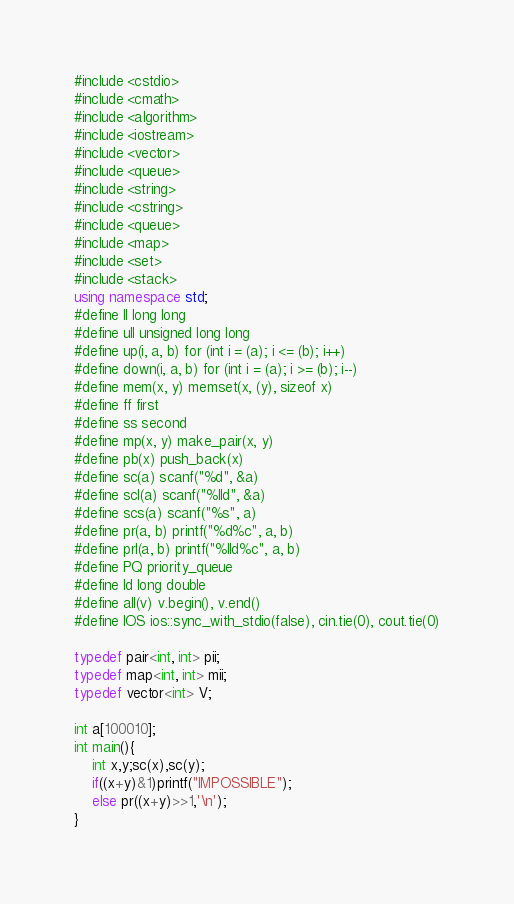Convert code to text. <code><loc_0><loc_0><loc_500><loc_500><_C++_>#include <cstdio>
#include <cmath>
#include <algorithm>
#include <iostream>
#include <vector>
#include <queue>
#include <string>
#include <cstring>
#include <queue>
#include <map>
#include <set>
#include <stack>
using namespace std;
#define ll long long
#define ull unsigned long long
#define up(i, a, b) for (int i = (a); i <= (b); i++)
#define down(i, a, b) for (int i = (a); i >= (b); i--)
#define mem(x, y) memset(x, (y), sizeof x)
#define ff first
#define ss second
#define mp(x, y) make_pair(x, y)
#define pb(x) push_back(x)
#define sc(a) scanf("%d", &a)
#define scl(a) scanf("%lld", &a)
#define scs(a) scanf("%s", a)
#define pr(a, b) printf("%d%c", a, b)
#define prl(a, b) printf("%lld%c", a, b)
#define PQ priority_queue
#define ld long double
#define all(v) v.begin(), v.end()
#define IOS ios::sync_with_stdio(false), cin.tie(0), cout.tie(0)

typedef pair<int, int> pii;
typedef map<int, int> mii;
typedef vector<int> V;

int a[100010];
int main(){
	int x,y;sc(x),sc(y);
	if((x+y)&1)printf("IMPOSSIBLE");
	else pr((x+y)>>1,'\n');
}</code> 